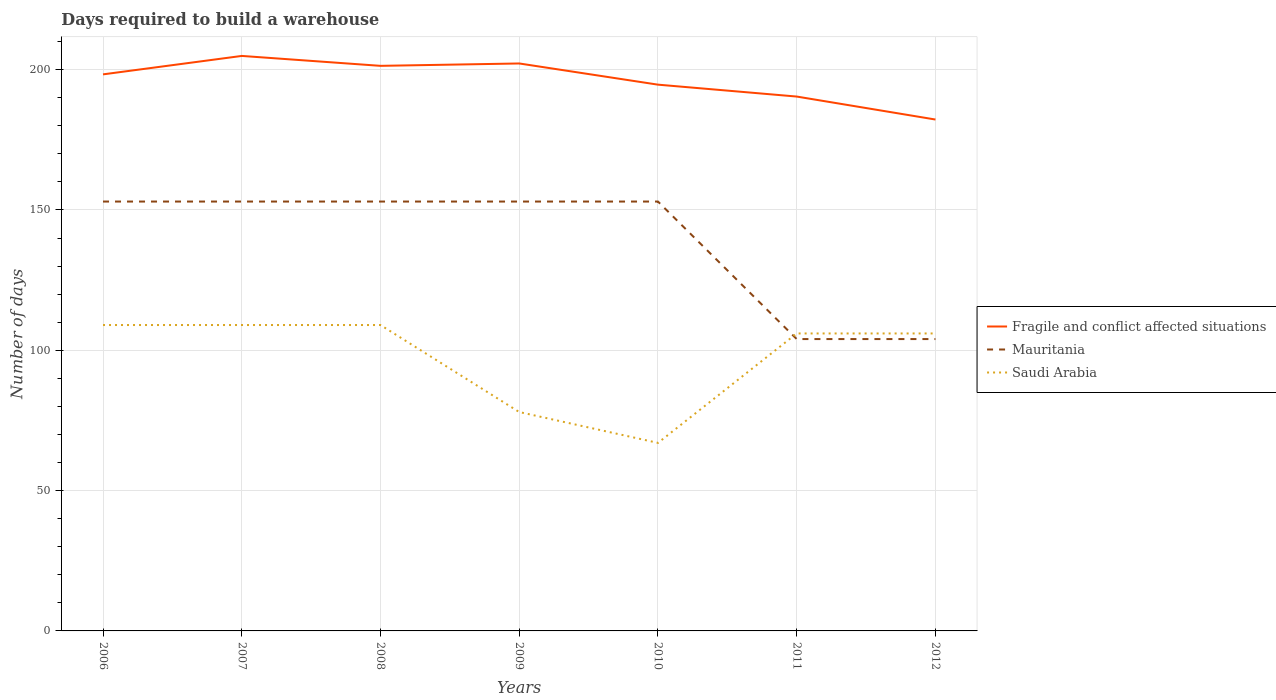Does the line corresponding to Fragile and conflict affected situations intersect with the line corresponding to Mauritania?
Your response must be concise. No. Is the number of lines equal to the number of legend labels?
Your response must be concise. Yes. Across all years, what is the maximum days required to build a warehouse in in Mauritania?
Your response must be concise. 104. In which year was the days required to build a warehouse in in Saudi Arabia maximum?
Your response must be concise. 2010. What is the total days required to build a warehouse in in Fragile and conflict affected situations in the graph?
Make the answer very short. 19.98. What is the difference between the highest and the second highest days required to build a warehouse in in Saudi Arabia?
Your response must be concise. 42. What is the difference between the highest and the lowest days required to build a warehouse in in Mauritania?
Your answer should be very brief. 5. How many years are there in the graph?
Your answer should be very brief. 7. What is the difference between two consecutive major ticks on the Y-axis?
Provide a short and direct response. 50. Are the values on the major ticks of Y-axis written in scientific E-notation?
Give a very brief answer. No. Does the graph contain grids?
Provide a short and direct response. Yes. Where does the legend appear in the graph?
Your answer should be compact. Center right. How are the legend labels stacked?
Make the answer very short. Vertical. What is the title of the graph?
Provide a succinct answer. Days required to build a warehouse. What is the label or title of the X-axis?
Offer a terse response. Years. What is the label or title of the Y-axis?
Give a very brief answer. Number of days. What is the Number of days in Fragile and conflict affected situations in 2006?
Provide a succinct answer. 198.32. What is the Number of days in Mauritania in 2006?
Ensure brevity in your answer.  153. What is the Number of days in Saudi Arabia in 2006?
Ensure brevity in your answer.  109. What is the Number of days in Fragile and conflict affected situations in 2007?
Give a very brief answer. 204.89. What is the Number of days in Mauritania in 2007?
Your response must be concise. 153. What is the Number of days of Saudi Arabia in 2007?
Ensure brevity in your answer.  109. What is the Number of days of Fragile and conflict affected situations in 2008?
Your response must be concise. 201.36. What is the Number of days in Mauritania in 2008?
Your answer should be very brief. 153. What is the Number of days in Saudi Arabia in 2008?
Provide a short and direct response. 109. What is the Number of days of Fragile and conflict affected situations in 2009?
Your answer should be compact. 202.21. What is the Number of days in Mauritania in 2009?
Offer a terse response. 153. What is the Number of days in Fragile and conflict affected situations in 2010?
Your answer should be very brief. 194.66. What is the Number of days in Mauritania in 2010?
Keep it short and to the point. 153. What is the Number of days of Fragile and conflict affected situations in 2011?
Provide a short and direct response. 190.41. What is the Number of days of Mauritania in 2011?
Ensure brevity in your answer.  104. What is the Number of days of Saudi Arabia in 2011?
Keep it short and to the point. 106. What is the Number of days in Fragile and conflict affected situations in 2012?
Keep it short and to the point. 182.23. What is the Number of days in Mauritania in 2012?
Your answer should be very brief. 104. What is the Number of days of Saudi Arabia in 2012?
Your answer should be compact. 106. Across all years, what is the maximum Number of days of Fragile and conflict affected situations?
Your response must be concise. 204.89. Across all years, what is the maximum Number of days in Mauritania?
Your response must be concise. 153. Across all years, what is the maximum Number of days of Saudi Arabia?
Your answer should be very brief. 109. Across all years, what is the minimum Number of days of Fragile and conflict affected situations?
Your response must be concise. 182.23. Across all years, what is the minimum Number of days in Mauritania?
Offer a very short reply. 104. Across all years, what is the minimum Number of days in Saudi Arabia?
Your response must be concise. 67. What is the total Number of days in Fragile and conflict affected situations in the graph?
Provide a succinct answer. 1374.07. What is the total Number of days in Mauritania in the graph?
Provide a succinct answer. 973. What is the total Number of days in Saudi Arabia in the graph?
Offer a terse response. 684. What is the difference between the Number of days of Fragile and conflict affected situations in 2006 and that in 2007?
Ensure brevity in your answer.  -6.57. What is the difference between the Number of days of Mauritania in 2006 and that in 2007?
Keep it short and to the point. 0. What is the difference between the Number of days in Fragile and conflict affected situations in 2006 and that in 2008?
Offer a terse response. -3.04. What is the difference between the Number of days in Mauritania in 2006 and that in 2008?
Offer a terse response. 0. What is the difference between the Number of days of Fragile and conflict affected situations in 2006 and that in 2009?
Offer a terse response. -3.89. What is the difference between the Number of days of Saudi Arabia in 2006 and that in 2009?
Ensure brevity in your answer.  31. What is the difference between the Number of days of Fragile and conflict affected situations in 2006 and that in 2010?
Your response must be concise. 3.67. What is the difference between the Number of days of Mauritania in 2006 and that in 2010?
Keep it short and to the point. 0. What is the difference between the Number of days of Fragile and conflict affected situations in 2006 and that in 2011?
Give a very brief answer. 7.91. What is the difference between the Number of days in Mauritania in 2006 and that in 2011?
Ensure brevity in your answer.  49. What is the difference between the Number of days in Fragile and conflict affected situations in 2006 and that in 2012?
Keep it short and to the point. 16.1. What is the difference between the Number of days in Fragile and conflict affected situations in 2007 and that in 2008?
Offer a terse response. 3.54. What is the difference between the Number of days in Fragile and conflict affected situations in 2007 and that in 2009?
Provide a short and direct response. 2.69. What is the difference between the Number of days in Saudi Arabia in 2007 and that in 2009?
Ensure brevity in your answer.  31. What is the difference between the Number of days in Fragile and conflict affected situations in 2007 and that in 2010?
Offer a terse response. 10.24. What is the difference between the Number of days of Saudi Arabia in 2007 and that in 2010?
Offer a very short reply. 42. What is the difference between the Number of days of Fragile and conflict affected situations in 2007 and that in 2011?
Give a very brief answer. 14.48. What is the difference between the Number of days of Saudi Arabia in 2007 and that in 2011?
Offer a terse response. 3. What is the difference between the Number of days in Fragile and conflict affected situations in 2007 and that in 2012?
Ensure brevity in your answer.  22.67. What is the difference between the Number of days in Mauritania in 2007 and that in 2012?
Ensure brevity in your answer.  49. What is the difference between the Number of days in Fragile and conflict affected situations in 2008 and that in 2009?
Make the answer very short. -0.85. What is the difference between the Number of days in Mauritania in 2008 and that in 2009?
Make the answer very short. 0. What is the difference between the Number of days of Fragile and conflict affected situations in 2008 and that in 2010?
Give a very brief answer. 6.7. What is the difference between the Number of days in Mauritania in 2008 and that in 2010?
Your response must be concise. 0. What is the difference between the Number of days in Fragile and conflict affected situations in 2008 and that in 2011?
Your answer should be compact. 10.94. What is the difference between the Number of days in Fragile and conflict affected situations in 2008 and that in 2012?
Give a very brief answer. 19.13. What is the difference between the Number of days in Fragile and conflict affected situations in 2009 and that in 2010?
Provide a succinct answer. 7.55. What is the difference between the Number of days of Mauritania in 2009 and that in 2010?
Your answer should be compact. 0. What is the difference between the Number of days of Saudi Arabia in 2009 and that in 2010?
Keep it short and to the point. 11. What is the difference between the Number of days in Fragile and conflict affected situations in 2009 and that in 2011?
Offer a very short reply. 11.79. What is the difference between the Number of days of Mauritania in 2009 and that in 2011?
Your answer should be very brief. 49. What is the difference between the Number of days of Fragile and conflict affected situations in 2009 and that in 2012?
Ensure brevity in your answer.  19.98. What is the difference between the Number of days in Fragile and conflict affected situations in 2010 and that in 2011?
Your answer should be very brief. 4.24. What is the difference between the Number of days in Saudi Arabia in 2010 and that in 2011?
Your answer should be compact. -39. What is the difference between the Number of days of Fragile and conflict affected situations in 2010 and that in 2012?
Your answer should be compact. 12.43. What is the difference between the Number of days of Saudi Arabia in 2010 and that in 2012?
Keep it short and to the point. -39. What is the difference between the Number of days of Fragile and conflict affected situations in 2011 and that in 2012?
Your answer should be compact. 8.19. What is the difference between the Number of days in Fragile and conflict affected situations in 2006 and the Number of days in Mauritania in 2007?
Ensure brevity in your answer.  45.32. What is the difference between the Number of days in Fragile and conflict affected situations in 2006 and the Number of days in Saudi Arabia in 2007?
Your answer should be compact. 89.32. What is the difference between the Number of days of Fragile and conflict affected situations in 2006 and the Number of days of Mauritania in 2008?
Your response must be concise. 45.32. What is the difference between the Number of days of Fragile and conflict affected situations in 2006 and the Number of days of Saudi Arabia in 2008?
Your response must be concise. 89.32. What is the difference between the Number of days in Fragile and conflict affected situations in 2006 and the Number of days in Mauritania in 2009?
Ensure brevity in your answer.  45.32. What is the difference between the Number of days in Fragile and conflict affected situations in 2006 and the Number of days in Saudi Arabia in 2009?
Offer a terse response. 120.32. What is the difference between the Number of days of Mauritania in 2006 and the Number of days of Saudi Arabia in 2009?
Offer a terse response. 75. What is the difference between the Number of days in Fragile and conflict affected situations in 2006 and the Number of days in Mauritania in 2010?
Offer a terse response. 45.32. What is the difference between the Number of days of Fragile and conflict affected situations in 2006 and the Number of days of Saudi Arabia in 2010?
Give a very brief answer. 131.32. What is the difference between the Number of days in Fragile and conflict affected situations in 2006 and the Number of days in Mauritania in 2011?
Keep it short and to the point. 94.32. What is the difference between the Number of days of Fragile and conflict affected situations in 2006 and the Number of days of Saudi Arabia in 2011?
Keep it short and to the point. 92.32. What is the difference between the Number of days in Fragile and conflict affected situations in 2006 and the Number of days in Mauritania in 2012?
Your response must be concise. 94.32. What is the difference between the Number of days in Fragile and conflict affected situations in 2006 and the Number of days in Saudi Arabia in 2012?
Your response must be concise. 92.32. What is the difference between the Number of days in Fragile and conflict affected situations in 2007 and the Number of days in Mauritania in 2008?
Offer a very short reply. 51.89. What is the difference between the Number of days of Fragile and conflict affected situations in 2007 and the Number of days of Saudi Arabia in 2008?
Your response must be concise. 95.89. What is the difference between the Number of days in Fragile and conflict affected situations in 2007 and the Number of days in Mauritania in 2009?
Your response must be concise. 51.89. What is the difference between the Number of days in Fragile and conflict affected situations in 2007 and the Number of days in Saudi Arabia in 2009?
Keep it short and to the point. 126.89. What is the difference between the Number of days in Mauritania in 2007 and the Number of days in Saudi Arabia in 2009?
Your response must be concise. 75. What is the difference between the Number of days in Fragile and conflict affected situations in 2007 and the Number of days in Mauritania in 2010?
Provide a succinct answer. 51.89. What is the difference between the Number of days of Fragile and conflict affected situations in 2007 and the Number of days of Saudi Arabia in 2010?
Provide a succinct answer. 137.89. What is the difference between the Number of days of Mauritania in 2007 and the Number of days of Saudi Arabia in 2010?
Make the answer very short. 86. What is the difference between the Number of days of Fragile and conflict affected situations in 2007 and the Number of days of Mauritania in 2011?
Give a very brief answer. 100.89. What is the difference between the Number of days in Fragile and conflict affected situations in 2007 and the Number of days in Saudi Arabia in 2011?
Offer a very short reply. 98.89. What is the difference between the Number of days in Mauritania in 2007 and the Number of days in Saudi Arabia in 2011?
Your answer should be compact. 47. What is the difference between the Number of days of Fragile and conflict affected situations in 2007 and the Number of days of Mauritania in 2012?
Offer a terse response. 100.89. What is the difference between the Number of days of Fragile and conflict affected situations in 2007 and the Number of days of Saudi Arabia in 2012?
Your response must be concise. 98.89. What is the difference between the Number of days of Mauritania in 2007 and the Number of days of Saudi Arabia in 2012?
Give a very brief answer. 47. What is the difference between the Number of days of Fragile and conflict affected situations in 2008 and the Number of days of Mauritania in 2009?
Give a very brief answer. 48.36. What is the difference between the Number of days in Fragile and conflict affected situations in 2008 and the Number of days in Saudi Arabia in 2009?
Make the answer very short. 123.36. What is the difference between the Number of days of Mauritania in 2008 and the Number of days of Saudi Arabia in 2009?
Provide a succinct answer. 75. What is the difference between the Number of days in Fragile and conflict affected situations in 2008 and the Number of days in Mauritania in 2010?
Make the answer very short. 48.36. What is the difference between the Number of days in Fragile and conflict affected situations in 2008 and the Number of days in Saudi Arabia in 2010?
Keep it short and to the point. 134.36. What is the difference between the Number of days in Fragile and conflict affected situations in 2008 and the Number of days in Mauritania in 2011?
Offer a terse response. 97.36. What is the difference between the Number of days in Fragile and conflict affected situations in 2008 and the Number of days in Saudi Arabia in 2011?
Ensure brevity in your answer.  95.36. What is the difference between the Number of days of Mauritania in 2008 and the Number of days of Saudi Arabia in 2011?
Your answer should be very brief. 47. What is the difference between the Number of days in Fragile and conflict affected situations in 2008 and the Number of days in Mauritania in 2012?
Offer a very short reply. 97.36. What is the difference between the Number of days in Fragile and conflict affected situations in 2008 and the Number of days in Saudi Arabia in 2012?
Offer a very short reply. 95.36. What is the difference between the Number of days of Fragile and conflict affected situations in 2009 and the Number of days of Mauritania in 2010?
Provide a succinct answer. 49.21. What is the difference between the Number of days in Fragile and conflict affected situations in 2009 and the Number of days in Saudi Arabia in 2010?
Your answer should be compact. 135.21. What is the difference between the Number of days in Fragile and conflict affected situations in 2009 and the Number of days in Mauritania in 2011?
Your answer should be compact. 98.21. What is the difference between the Number of days of Fragile and conflict affected situations in 2009 and the Number of days of Saudi Arabia in 2011?
Provide a succinct answer. 96.21. What is the difference between the Number of days of Mauritania in 2009 and the Number of days of Saudi Arabia in 2011?
Provide a short and direct response. 47. What is the difference between the Number of days in Fragile and conflict affected situations in 2009 and the Number of days in Mauritania in 2012?
Give a very brief answer. 98.21. What is the difference between the Number of days of Fragile and conflict affected situations in 2009 and the Number of days of Saudi Arabia in 2012?
Give a very brief answer. 96.21. What is the difference between the Number of days in Fragile and conflict affected situations in 2010 and the Number of days in Mauritania in 2011?
Make the answer very short. 90.66. What is the difference between the Number of days of Fragile and conflict affected situations in 2010 and the Number of days of Saudi Arabia in 2011?
Give a very brief answer. 88.66. What is the difference between the Number of days in Mauritania in 2010 and the Number of days in Saudi Arabia in 2011?
Offer a terse response. 47. What is the difference between the Number of days of Fragile and conflict affected situations in 2010 and the Number of days of Mauritania in 2012?
Provide a succinct answer. 90.66. What is the difference between the Number of days of Fragile and conflict affected situations in 2010 and the Number of days of Saudi Arabia in 2012?
Give a very brief answer. 88.66. What is the difference between the Number of days in Fragile and conflict affected situations in 2011 and the Number of days in Mauritania in 2012?
Your answer should be very brief. 86.41. What is the difference between the Number of days of Fragile and conflict affected situations in 2011 and the Number of days of Saudi Arabia in 2012?
Make the answer very short. 84.41. What is the difference between the Number of days of Mauritania in 2011 and the Number of days of Saudi Arabia in 2012?
Offer a very short reply. -2. What is the average Number of days in Fragile and conflict affected situations per year?
Your answer should be compact. 196.3. What is the average Number of days of Mauritania per year?
Your answer should be very brief. 139. What is the average Number of days of Saudi Arabia per year?
Your response must be concise. 97.71. In the year 2006, what is the difference between the Number of days in Fragile and conflict affected situations and Number of days in Mauritania?
Provide a succinct answer. 45.32. In the year 2006, what is the difference between the Number of days in Fragile and conflict affected situations and Number of days in Saudi Arabia?
Make the answer very short. 89.32. In the year 2007, what is the difference between the Number of days in Fragile and conflict affected situations and Number of days in Mauritania?
Provide a succinct answer. 51.89. In the year 2007, what is the difference between the Number of days in Fragile and conflict affected situations and Number of days in Saudi Arabia?
Your answer should be compact. 95.89. In the year 2007, what is the difference between the Number of days in Mauritania and Number of days in Saudi Arabia?
Your answer should be compact. 44. In the year 2008, what is the difference between the Number of days of Fragile and conflict affected situations and Number of days of Mauritania?
Make the answer very short. 48.36. In the year 2008, what is the difference between the Number of days in Fragile and conflict affected situations and Number of days in Saudi Arabia?
Provide a short and direct response. 92.36. In the year 2008, what is the difference between the Number of days in Mauritania and Number of days in Saudi Arabia?
Provide a succinct answer. 44. In the year 2009, what is the difference between the Number of days of Fragile and conflict affected situations and Number of days of Mauritania?
Give a very brief answer. 49.21. In the year 2009, what is the difference between the Number of days of Fragile and conflict affected situations and Number of days of Saudi Arabia?
Your response must be concise. 124.21. In the year 2010, what is the difference between the Number of days in Fragile and conflict affected situations and Number of days in Mauritania?
Provide a succinct answer. 41.66. In the year 2010, what is the difference between the Number of days of Fragile and conflict affected situations and Number of days of Saudi Arabia?
Offer a terse response. 127.66. In the year 2010, what is the difference between the Number of days of Mauritania and Number of days of Saudi Arabia?
Your response must be concise. 86. In the year 2011, what is the difference between the Number of days in Fragile and conflict affected situations and Number of days in Mauritania?
Offer a terse response. 86.41. In the year 2011, what is the difference between the Number of days of Fragile and conflict affected situations and Number of days of Saudi Arabia?
Your response must be concise. 84.41. In the year 2011, what is the difference between the Number of days of Mauritania and Number of days of Saudi Arabia?
Your response must be concise. -2. In the year 2012, what is the difference between the Number of days of Fragile and conflict affected situations and Number of days of Mauritania?
Your response must be concise. 78.23. In the year 2012, what is the difference between the Number of days of Fragile and conflict affected situations and Number of days of Saudi Arabia?
Offer a terse response. 76.23. What is the ratio of the Number of days of Fragile and conflict affected situations in 2006 to that in 2007?
Keep it short and to the point. 0.97. What is the ratio of the Number of days in Fragile and conflict affected situations in 2006 to that in 2008?
Offer a very short reply. 0.98. What is the ratio of the Number of days in Mauritania in 2006 to that in 2008?
Offer a terse response. 1. What is the ratio of the Number of days in Fragile and conflict affected situations in 2006 to that in 2009?
Offer a very short reply. 0.98. What is the ratio of the Number of days of Mauritania in 2006 to that in 2009?
Keep it short and to the point. 1. What is the ratio of the Number of days of Saudi Arabia in 2006 to that in 2009?
Your answer should be very brief. 1.4. What is the ratio of the Number of days of Fragile and conflict affected situations in 2006 to that in 2010?
Your answer should be compact. 1.02. What is the ratio of the Number of days in Mauritania in 2006 to that in 2010?
Offer a terse response. 1. What is the ratio of the Number of days in Saudi Arabia in 2006 to that in 2010?
Keep it short and to the point. 1.63. What is the ratio of the Number of days in Fragile and conflict affected situations in 2006 to that in 2011?
Your answer should be very brief. 1.04. What is the ratio of the Number of days in Mauritania in 2006 to that in 2011?
Ensure brevity in your answer.  1.47. What is the ratio of the Number of days in Saudi Arabia in 2006 to that in 2011?
Make the answer very short. 1.03. What is the ratio of the Number of days in Fragile and conflict affected situations in 2006 to that in 2012?
Your response must be concise. 1.09. What is the ratio of the Number of days in Mauritania in 2006 to that in 2012?
Offer a very short reply. 1.47. What is the ratio of the Number of days in Saudi Arabia in 2006 to that in 2012?
Make the answer very short. 1.03. What is the ratio of the Number of days of Fragile and conflict affected situations in 2007 to that in 2008?
Provide a short and direct response. 1.02. What is the ratio of the Number of days of Fragile and conflict affected situations in 2007 to that in 2009?
Make the answer very short. 1.01. What is the ratio of the Number of days in Mauritania in 2007 to that in 2009?
Your response must be concise. 1. What is the ratio of the Number of days of Saudi Arabia in 2007 to that in 2009?
Make the answer very short. 1.4. What is the ratio of the Number of days of Fragile and conflict affected situations in 2007 to that in 2010?
Your answer should be compact. 1.05. What is the ratio of the Number of days of Saudi Arabia in 2007 to that in 2010?
Keep it short and to the point. 1.63. What is the ratio of the Number of days in Fragile and conflict affected situations in 2007 to that in 2011?
Your response must be concise. 1.08. What is the ratio of the Number of days of Mauritania in 2007 to that in 2011?
Give a very brief answer. 1.47. What is the ratio of the Number of days of Saudi Arabia in 2007 to that in 2011?
Offer a terse response. 1.03. What is the ratio of the Number of days of Fragile and conflict affected situations in 2007 to that in 2012?
Give a very brief answer. 1.12. What is the ratio of the Number of days in Mauritania in 2007 to that in 2012?
Give a very brief answer. 1.47. What is the ratio of the Number of days of Saudi Arabia in 2007 to that in 2012?
Ensure brevity in your answer.  1.03. What is the ratio of the Number of days in Mauritania in 2008 to that in 2009?
Your answer should be compact. 1. What is the ratio of the Number of days in Saudi Arabia in 2008 to that in 2009?
Provide a short and direct response. 1.4. What is the ratio of the Number of days in Fragile and conflict affected situations in 2008 to that in 2010?
Offer a terse response. 1.03. What is the ratio of the Number of days in Saudi Arabia in 2008 to that in 2010?
Ensure brevity in your answer.  1.63. What is the ratio of the Number of days of Fragile and conflict affected situations in 2008 to that in 2011?
Keep it short and to the point. 1.06. What is the ratio of the Number of days in Mauritania in 2008 to that in 2011?
Your answer should be very brief. 1.47. What is the ratio of the Number of days in Saudi Arabia in 2008 to that in 2011?
Your answer should be very brief. 1.03. What is the ratio of the Number of days in Fragile and conflict affected situations in 2008 to that in 2012?
Give a very brief answer. 1.1. What is the ratio of the Number of days in Mauritania in 2008 to that in 2012?
Provide a short and direct response. 1.47. What is the ratio of the Number of days in Saudi Arabia in 2008 to that in 2012?
Your answer should be very brief. 1.03. What is the ratio of the Number of days of Fragile and conflict affected situations in 2009 to that in 2010?
Your answer should be compact. 1.04. What is the ratio of the Number of days of Mauritania in 2009 to that in 2010?
Ensure brevity in your answer.  1. What is the ratio of the Number of days of Saudi Arabia in 2009 to that in 2010?
Give a very brief answer. 1.16. What is the ratio of the Number of days of Fragile and conflict affected situations in 2009 to that in 2011?
Your answer should be very brief. 1.06. What is the ratio of the Number of days of Mauritania in 2009 to that in 2011?
Your answer should be compact. 1.47. What is the ratio of the Number of days in Saudi Arabia in 2009 to that in 2011?
Ensure brevity in your answer.  0.74. What is the ratio of the Number of days of Fragile and conflict affected situations in 2009 to that in 2012?
Make the answer very short. 1.11. What is the ratio of the Number of days in Mauritania in 2009 to that in 2012?
Offer a terse response. 1.47. What is the ratio of the Number of days in Saudi Arabia in 2009 to that in 2012?
Give a very brief answer. 0.74. What is the ratio of the Number of days in Fragile and conflict affected situations in 2010 to that in 2011?
Offer a terse response. 1.02. What is the ratio of the Number of days in Mauritania in 2010 to that in 2011?
Make the answer very short. 1.47. What is the ratio of the Number of days of Saudi Arabia in 2010 to that in 2011?
Your response must be concise. 0.63. What is the ratio of the Number of days of Fragile and conflict affected situations in 2010 to that in 2012?
Keep it short and to the point. 1.07. What is the ratio of the Number of days in Mauritania in 2010 to that in 2012?
Provide a succinct answer. 1.47. What is the ratio of the Number of days in Saudi Arabia in 2010 to that in 2012?
Your answer should be compact. 0.63. What is the ratio of the Number of days of Fragile and conflict affected situations in 2011 to that in 2012?
Offer a terse response. 1.04. What is the difference between the highest and the second highest Number of days in Fragile and conflict affected situations?
Provide a short and direct response. 2.69. What is the difference between the highest and the lowest Number of days in Fragile and conflict affected situations?
Offer a very short reply. 22.67. What is the difference between the highest and the lowest Number of days in Saudi Arabia?
Ensure brevity in your answer.  42. 